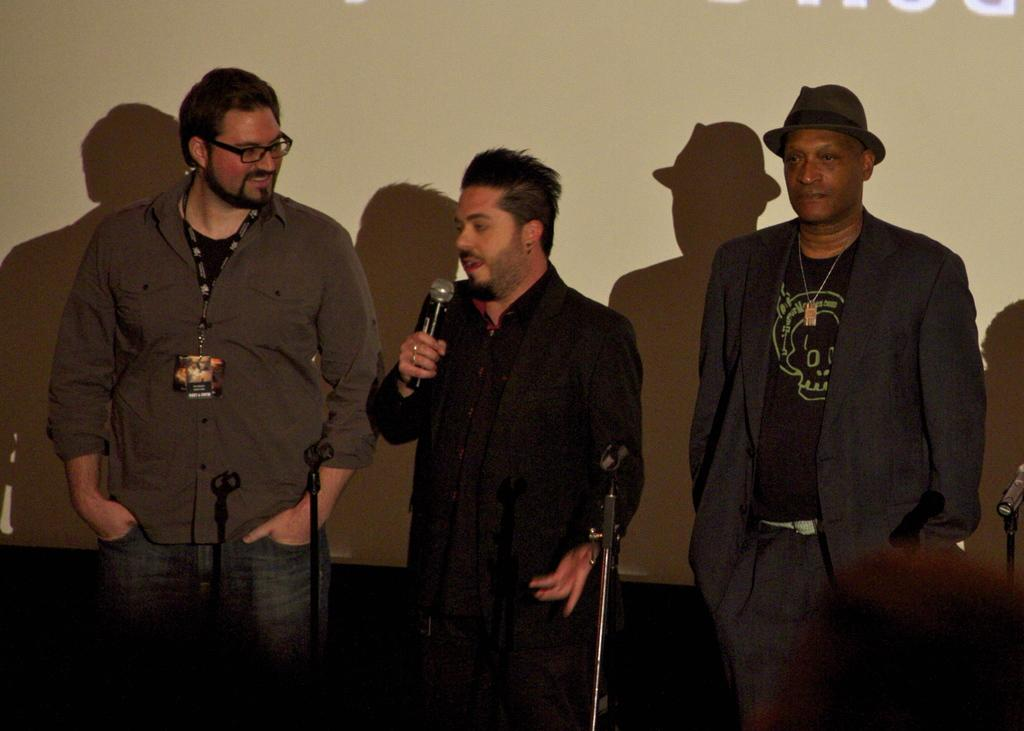How many people are in the image? There are three persons in the image. What are the people in the image doing? The persons are standing, and the person in the center is holding a microphone and speaking. Can you describe the facial expression of the person on the left side? The person on the left side is smiling. What type of dolls can be seen solving a riddle in the image? There are no dolls present in the image, and no riddles are being solved. 